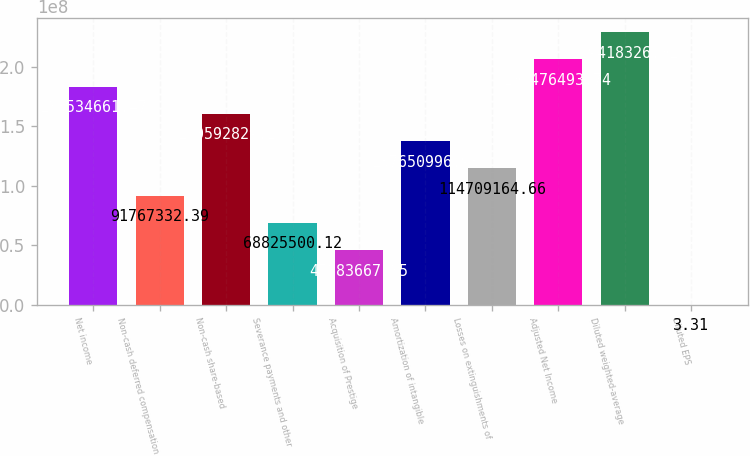Convert chart to OTSL. <chart><loc_0><loc_0><loc_500><loc_500><bar_chart><fcel>Net income<fcel>Non-cash deferred compensation<fcel>Non-cash share-based<fcel>Severance payments and other<fcel>Acquisition of Prestige<fcel>Amortization of intangible<fcel>Losses on extinguishments of<fcel>Adjusted Net Income<fcel>Diluted weighted-average<fcel>Diluted EPS<nl><fcel>1.83535e+08<fcel>9.17673e+07<fcel>1.60593e+08<fcel>6.88255e+07<fcel>4.58837e+07<fcel>1.37651e+08<fcel>1.14709e+08<fcel>2.06476e+08<fcel>2.29418e+08<fcel>3.31<nl></chart> 